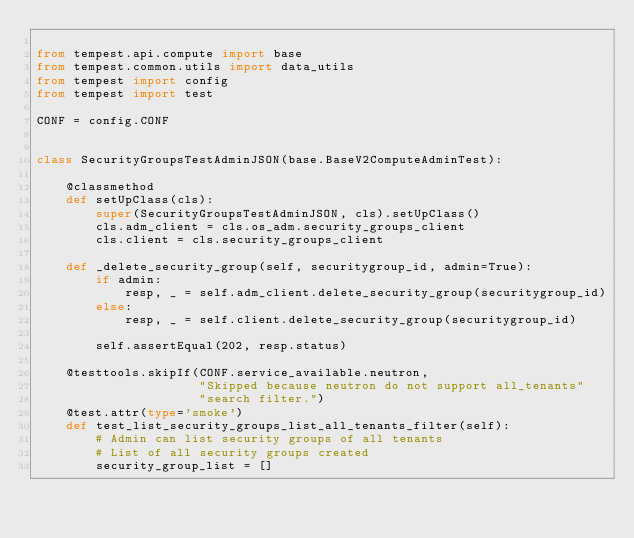<code> <loc_0><loc_0><loc_500><loc_500><_Python_>
from tempest.api.compute import base
from tempest.common.utils import data_utils
from tempest import config
from tempest import test

CONF = config.CONF


class SecurityGroupsTestAdminJSON(base.BaseV2ComputeAdminTest):

    @classmethod
    def setUpClass(cls):
        super(SecurityGroupsTestAdminJSON, cls).setUpClass()
        cls.adm_client = cls.os_adm.security_groups_client
        cls.client = cls.security_groups_client

    def _delete_security_group(self, securitygroup_id, admin=True):
        if admin:
            resp, _ = self.adm_client.delete_security_group(securitygroup_id)
        else:
            resp, _ = self.client.delete_security_group(securitygroup_id)

        self.assertEqual(202, resp.status)

    @testtools.skipIf(CONF.service_available.neutron,
                      "Skipped because neutron do not support all_tenants"
                      "search filter.")
    @test.attr(type='smoke')
    def test_list_security_groups_list_all_tenants_filter(self):
        # Admin can list security groups of all tenants
        # List of all security groups created
        security_group_list = []</code> 